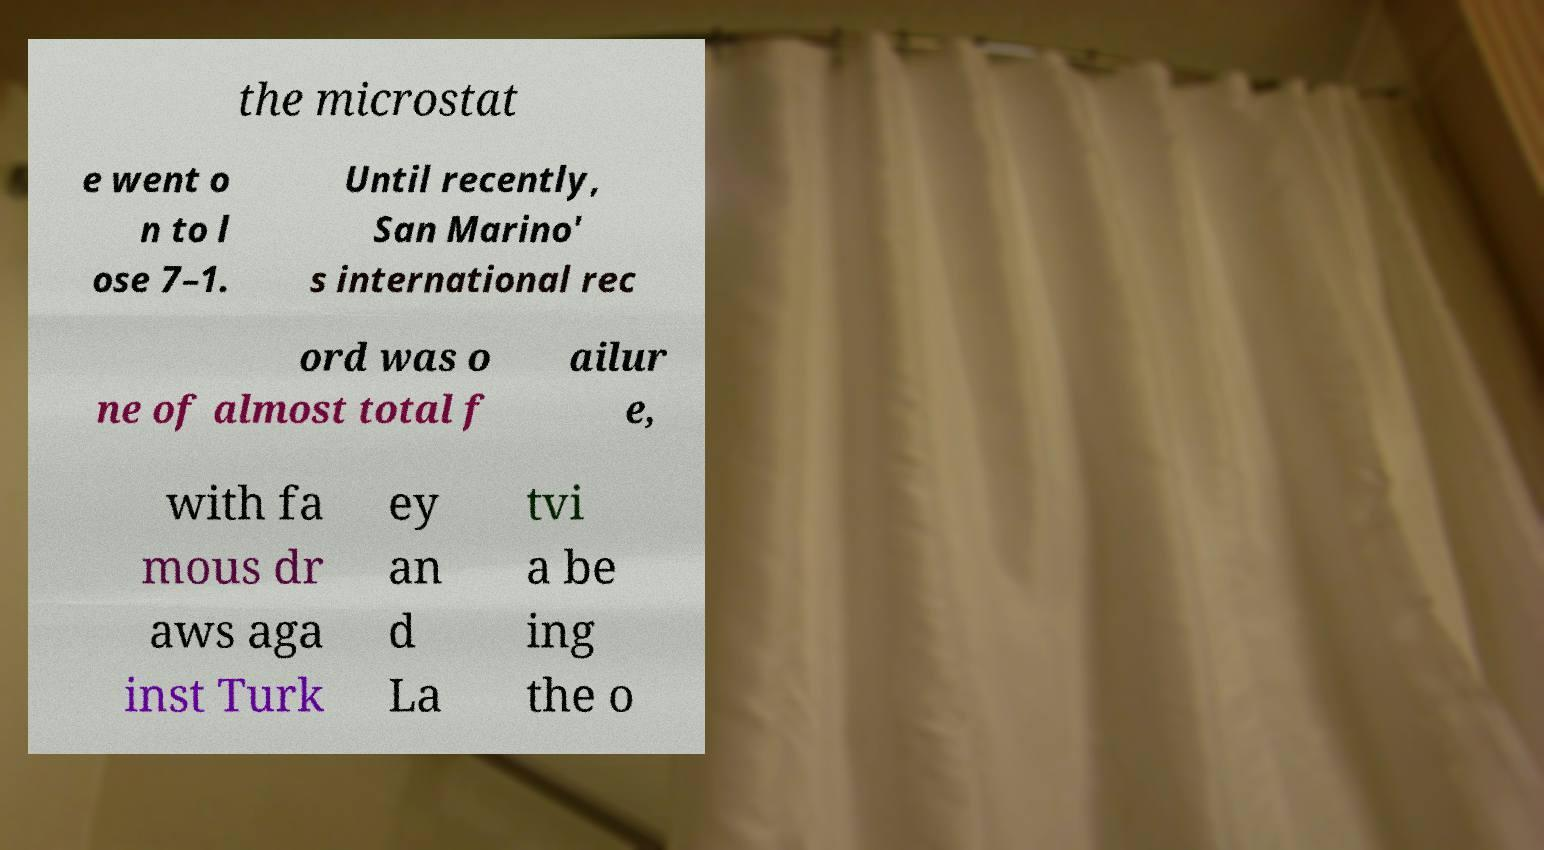Could you assist in decoding the text presented in this image and type it out clearly? the microstat e went o n to l ose 7–1. Until recently, San Marino' s international rec ord was o ne of almost total f ailur e, with fa mous dr aws aga inst Turk ey an d La tvi a be ing the o 